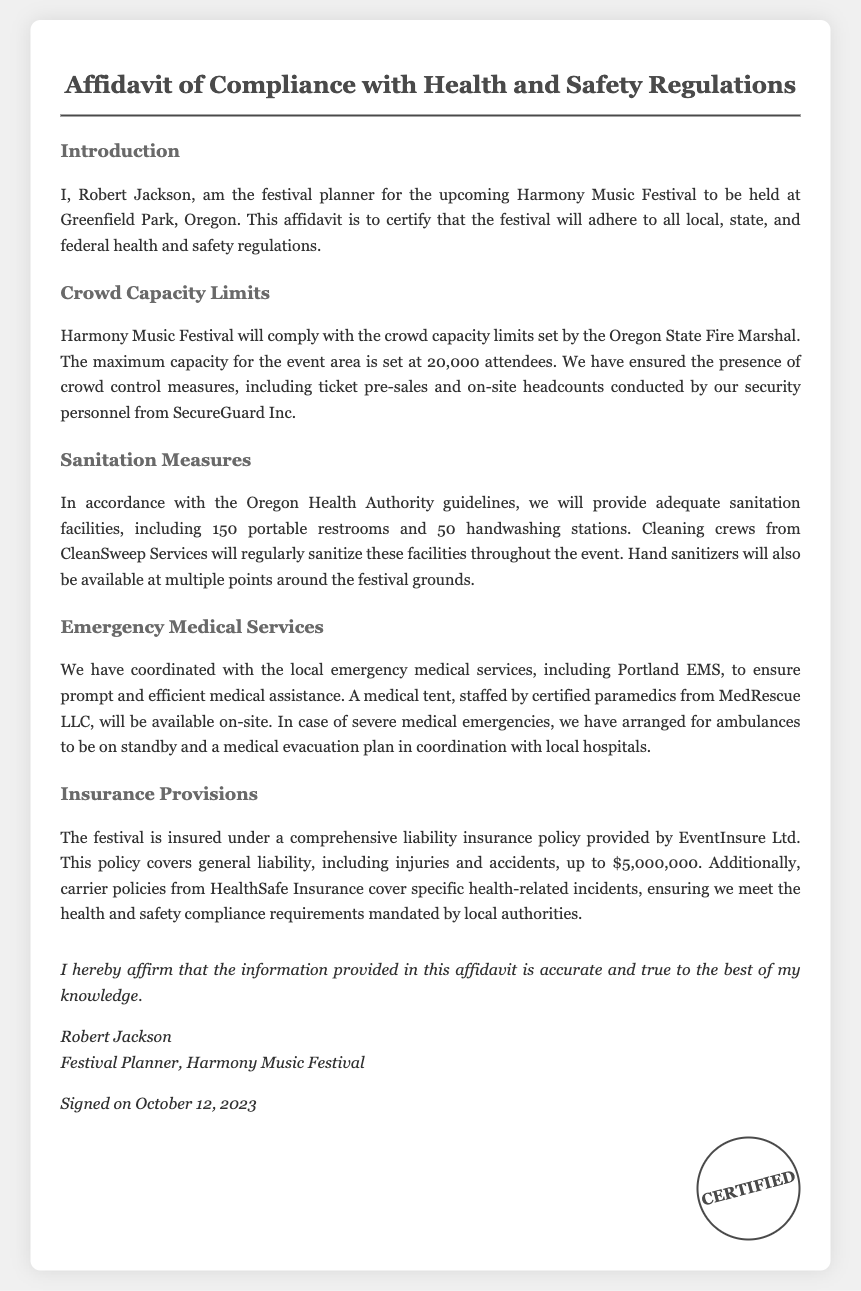What is the maximum capacity for Harmony Music Festival? The document states that the maximum capacity for the event area is set at 20,000 attendees.
Answer: 20,000 attendees Who is the festival planner? The affidavit mentions Robert Jackson as the festival planner for Harmony Music Festival.
Answer: Robert Jackson What company is responsible for the festival's sanitation services? The sanitation measures are provided by CleanSweep Services, as specified in the document.
Answer: CleanSweep Services What is the total coverage amount of the liability insurance policy? The document specifies that the liability insurance policy covers up to $5,000,000 for general liability.
Answer: $5,000,000 When was the affidavit signed? The affidavit indicates that it was signed on October 12, 2023.
Answer: October 12, 2023 Which emergency medical service is coordinated with the festival? The document mentions that Portland EMS is the local emergency medical service coordinated for the festival.
Answer: Portland EMS What type of restrooms will be provided at the festival? The sanitation measures include 150 portable restrooms as stated in the document.
Answer: Portable restrooms What is the name of the medical staffing company for the festival? The affidavit specifies that certified paramedics from MedRescue LLC will staff the medical tent.
Answer: MedRescue LLC What type of insurance covers health-related incidents? HealthSafe Insurance is indicated as covering specific health-related incidents in accordance with the document.
Answer: HealthSafe Insurance 